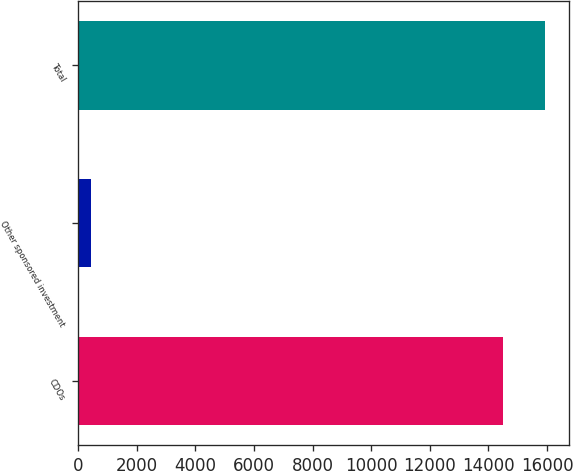<chart> <loc_0><loc_0><loc_500><loc_500><bar_chart><fcel>CDOs<fcel>Other sponsored investment<fcel>Total<nl><fcel>14487<fcel>440<fcel>15935.7<nl></chart> 